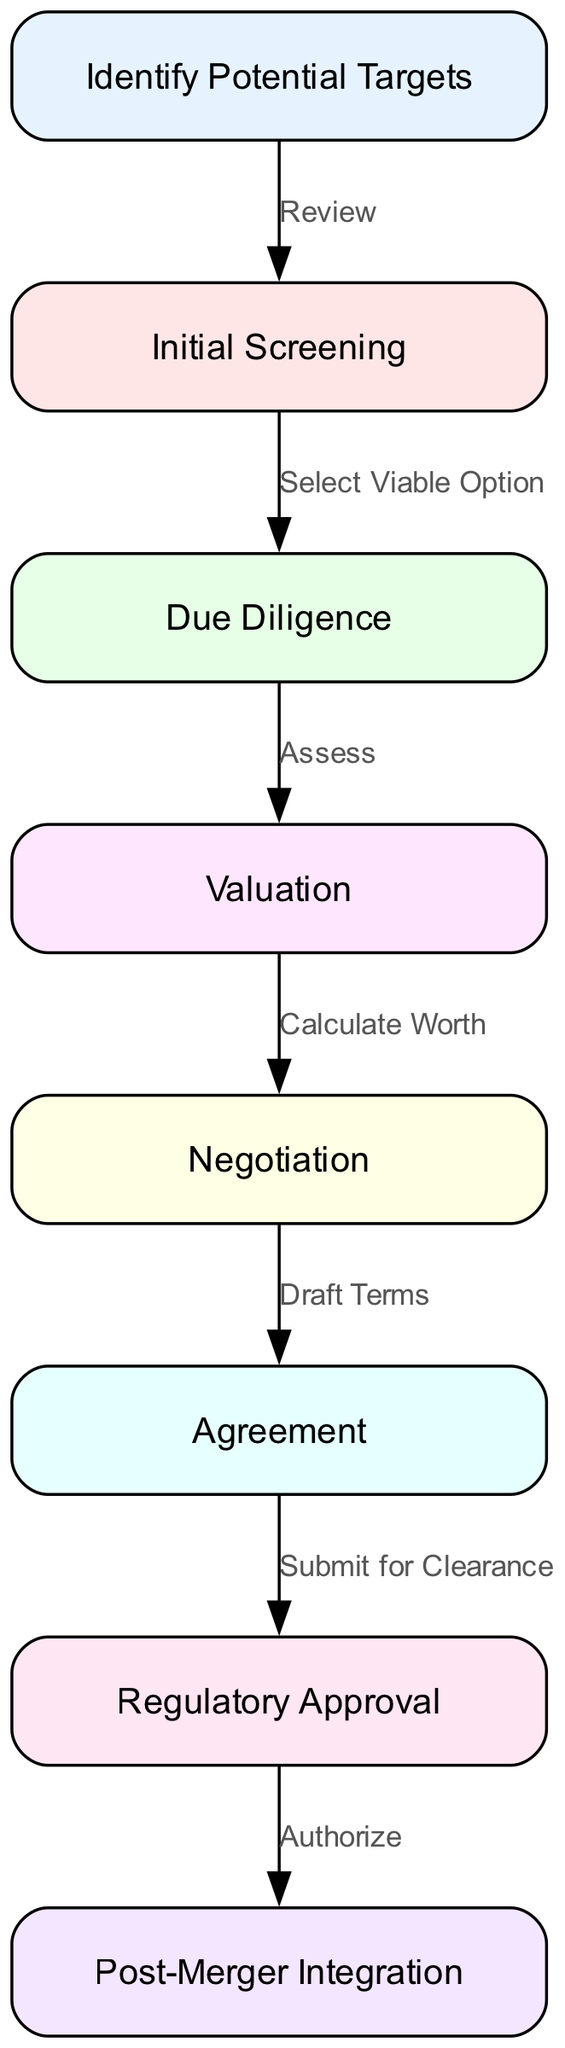What is the first step in the decision-making process? The first step in the diagram, denoted by the node labeled "Identify Potential Targets," initiates the flow of the decision-making process in mergers and acquisitions.
Answer: Identify Potential Targets How many nodes are there in the diagram? Counting each distinct labeled node in the diagram provides the total number of nodes, which are: Identify Potential Targets, Initial Screening, Due Diligence, Valuation, Negotiation, Agreement, Regulatory Approval, and Post-Merger Integration. This sums up to eight nodes.
Answer: 8 What action follows due diligence? From the "Due Diligence" node, the next action in the flow is indicated to be "Valuation," which is the subsequent node linked by the edge labeled "Assess."
Answer: Valuation Which two nodes are directly connected by the edge labeled "Draft Terms"? The edge labeled "Draft Terms" connects "Negotiation" to "Agreement," indicating the direct relationship between these two steps in the process.
Answer: Negotiation and Agreement What is the final step in the decision-making process? The last node in the flowchart is "Post-Merger Integration," which concludes the decision-making process in the context of mergers and acquisitions.
Answer: Post-Merger Integration What is the relationship between the "Agreement" and "Regulatory Approval" nodes? The "Agreement" node leads directly to the "Regulatory Approval" node through the edge labeled "Submit for Clearance," indicating that once the agreement is reached, it must be submitted for regulatory clearance.
Answer: Submit for Clearance What is the number of edges in the diagram? By counting all connections between the nodes, the total number of edges is calculated: Identify Potential Targets to Initial Screening, Initial Screening to Due Diligence, Due Diligence to Valuation, Valuation to Negotiation, Negotiation to Agreement, Agreement to Regulatory Approval, and Regulatory Approval to Post-Merger Integration; this totals to seven edges.
Answer: 7 Which node indicates the assessment phase? The node labeled "Due Diligence" signifies the assessment phase in the decision-making process, as indicated by the flow leading into the subsequent step of valuation.
Answer: Due Diligence 